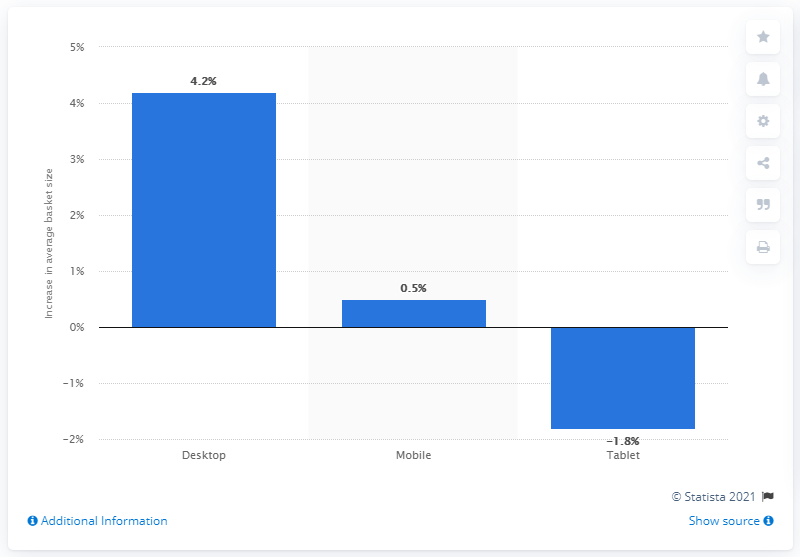Could this trend have any impact on market strategies for tech companies? Absolutely. If tech companies observed this data, they might strategize to invest more in desktop computer technology, innovation, and marketing. They might also evaluate their mobile device offerings to ensure they remain competitive, considering the minor growth. For tablets, companies could investigate the decline and potentially revamp their tablet products, or else pivot to the more popular device segments in their portfolios. 